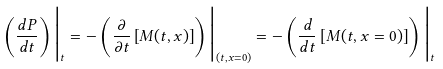Convert formula to latex. <formula><loc_0><loc_0><loc_500><loc_500>\left ( \frac { d P } { d t } \right ) \Big { | } _ { t } = - \left ( \frac { \partial } { \partial t } \left [ M ( t , x ) \right ] \right ) \Big { | } _ { ( t , x = 0 ) } = - \left ( \frac { d } { d t } \left [ M ( t , x = 0 ) \right ] \right ) \Big { | } _ { t }</formula> 